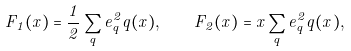<formula> <loc_0><loc_0><loc_500><loc_500>F _ { 1 } ( x ) = \frac { 1 } { 2 } \sum _ { q } e _ { q } ^ { 2 } q ( x ) , \quad F _ { 2 } ( x ) = x \sum _ { q } e _ { q } ^ { 2 } q ( x ) ,</formula> 